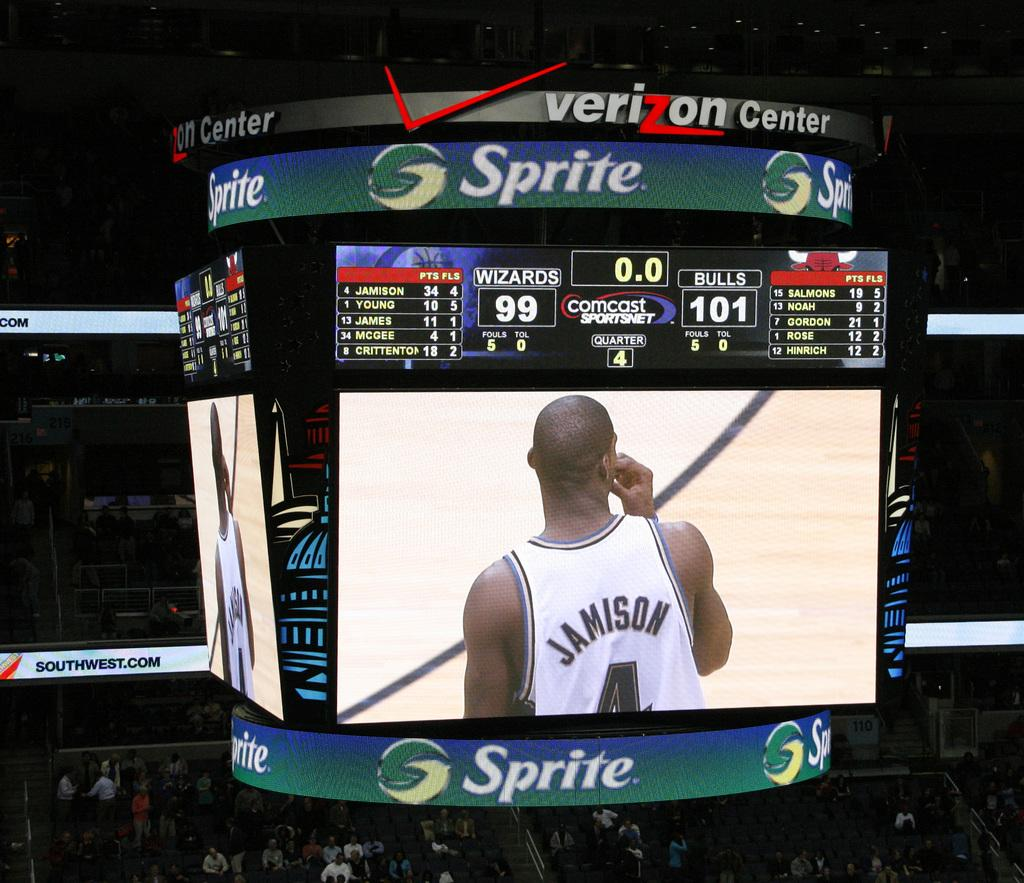<image>
Offer a succinct explanation of the picture presented. The scoreboard at the Verizon Center is partially sponsored by Sprite. 